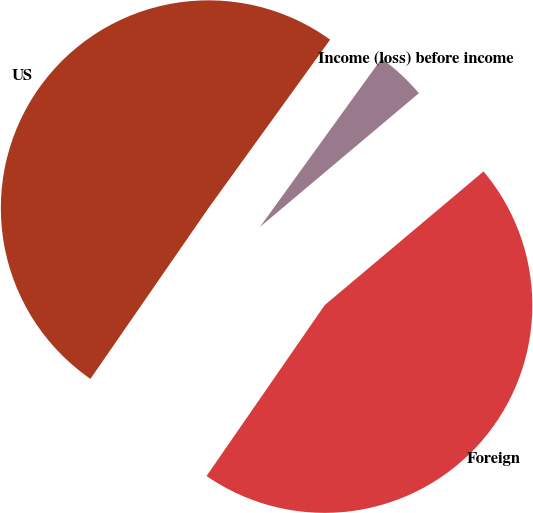<chart> <loc_0><loc_0><loc_500><loc_500><pie_chart><fcel>US<fcel>Foreign<fcel>Income (loss) before income<nl><fcel>50.33%<fcel>45.76%<fcel>3.91%<nl></chart> 